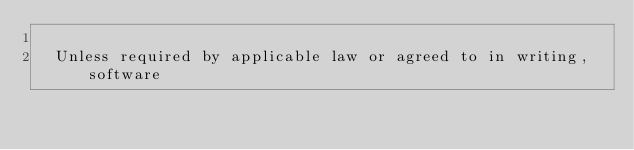<code> <loc_0><loc_0><loc_500><loc_500><_XML_>
  Unless required by applicable law or agreed to in writing, software</code> 